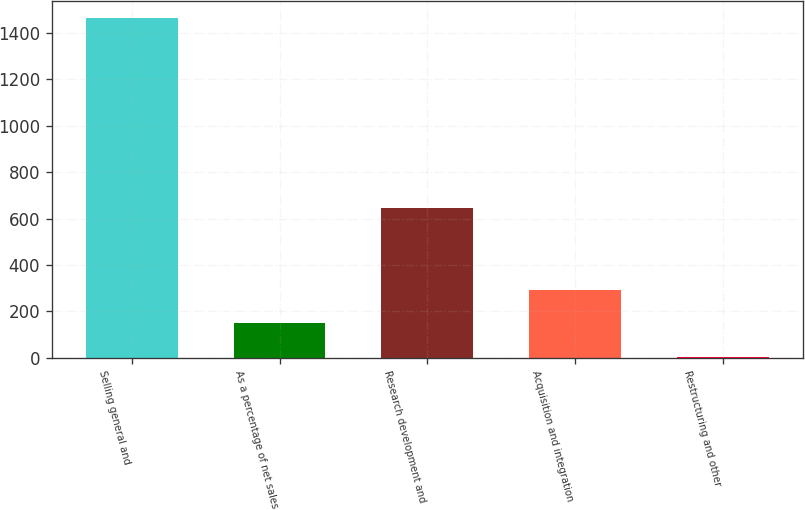Convert chart to OTSL. <chart><loc_0><loc_0><loc_500><loc_500><bar_chart><fcel>Selling general and<fcel>As a percentage of net sales<fcel>Research development and<fcel>Acquisition and integration<fcel>Restructuring and other<nl><fcel>1463<fcel>148.1<fcel>644<fcel>294.2<fcel>2<nl></chart> 